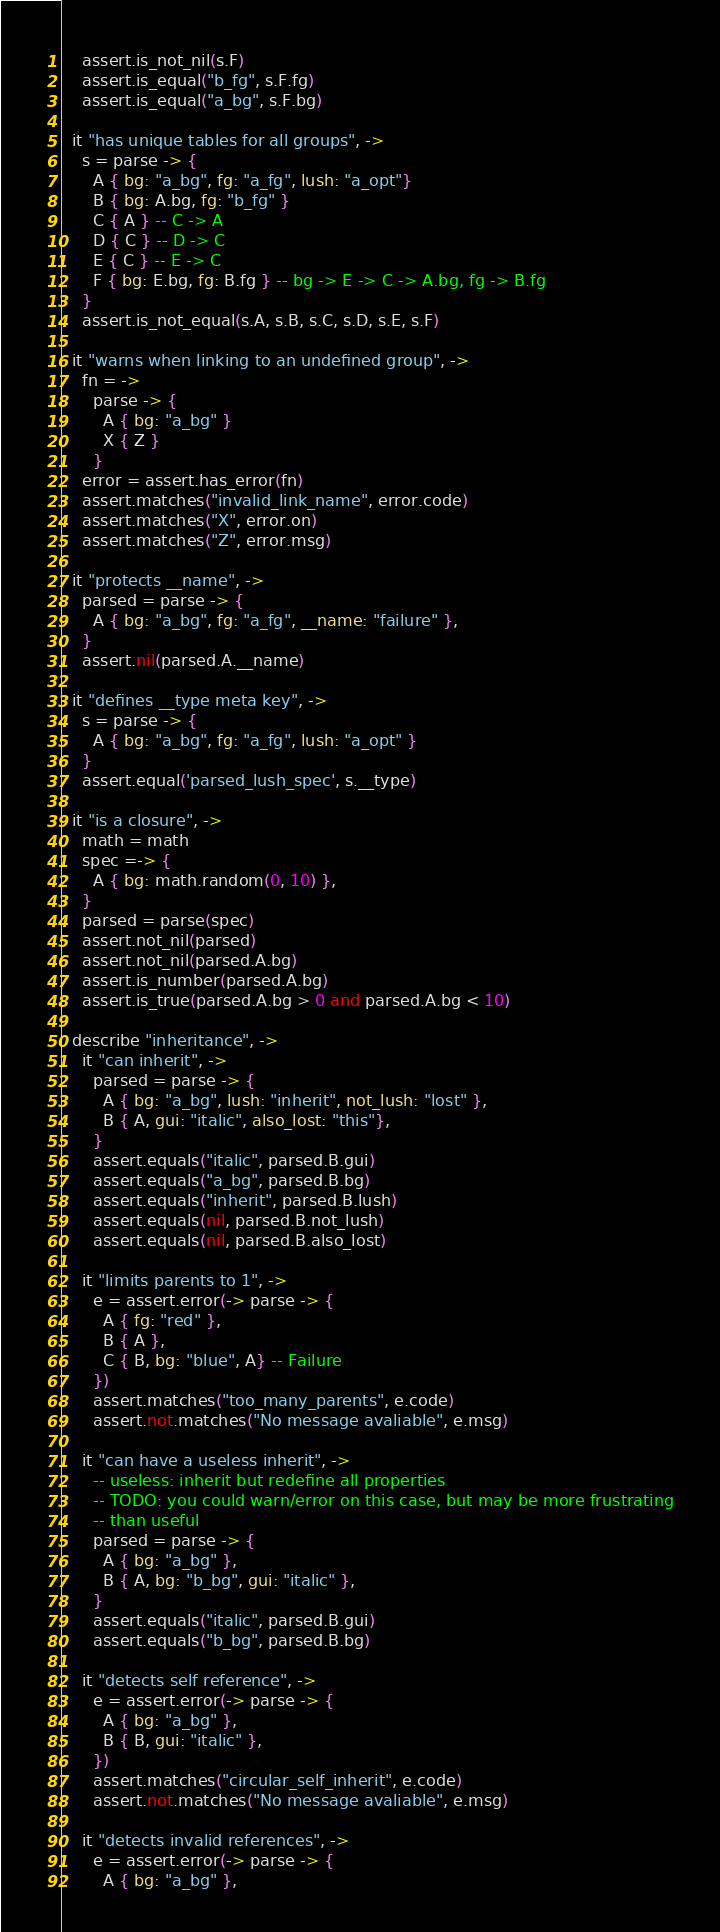Convert code to text. <code><loc_0><loc_0><loc_500><loc_500><_MoonScript_>    assert.is_not_nil(s.F)
    assert.is_equal("b_fg", s.F.fg)
    assert.is_equal("a_bg", s.F.bg)

  it "has unique tables for all groups", ->
    s = parse -> {
      A { bg: "a_bg", fg: "a_fg", lush: "a_opt"}
      B { bg: A.bg, fg: "b_fg" }
      C { A } -- C -> A
      D { C } -- D -> C
      E { C } -- E -> C
      F { bg: E.bg, fg: B.fg } -- bg -> E -> C -> A.bg, fg -> B.fg
    }
    assert.is_not_equal(s.A, s.B, s.C, s.D, s.E, s.F)

  it "warns when linking to an undefined group", ->
    fn = ->
      parse -> {
        A { bg: "a_bg" }
        X { Z }
      }
    error = assert.has_error(fn)
    assert.matches("invalid_link_name", error.code)
    assert.matches("X", error.on)
    assert.matches("Z", error.msg)

  it "protects __name", ->
    parsed = parse -> {
      A { bg: "a_bg", fg: "a_fg", __name: "failure" },
    }
    assert.nil(parsed.A.__name)

  it "defines __type meta key", ->
    s = parse -> {
      A { bg: "a_bg", fg: "a_fg", lush: "a_opt" }
    }
    assert.equal('parsed_lush_spec', s.__type)

  it "is a closure", ->
    math = math
    spec =-> {
      A { bg: math.random(0, 10) },
    }
    parsed = parse(spec)
    assert.not_nil(parsed)
    assert.not_nil(parsed.A.bg)
    assert.is_number(parsed.A.bg)
    assert.is_true(parsed.A.bg > 0 and parsed.A.bg < 10)

  describe "inheritance", ->
    it "can inherit", ->
      parsed = parse -> {
        A { bg: "a_bg", lush: "inherit", not_lush: "lost" },
        B { A, gui: "italic", also_lost: "this"},
      }
      assert.equals("italic", parsed.B.gui)
      assert.equals("a_bg", parsed.B.bg)
      assert.equals("inherit", parsed.B.lush)
      assert.equals(nil, parsed.B.not_lush)
      assert.equals(nil, parsed.B.also_lost)

    it "limits parents to 1", ->
      e = assert.error(-> parse -> {
        A { fg: "red" },
        B { A },
        C { B, bg: "blue", A} -- Failure
      })
      assert.matches("too_many_parents", e.code)
      assert.not.matches("No message avaliable", e.msg)

    it "can have a useless inherit", ->
      -- useless: inherit but redefine all properties
      -- TODO: you could warn/error on this case, but may be more frustrating
      -- than useful
      parsed = parse -> {
        A { bg: "a_bg" },
        B { A, bg: "b_bg", gui: "italic" },
      }
      assert.equals("italic", parsed.B.gui)
      assert.equals("b_bg", parsed.B.bg)

    it "detects self reference", ->
      e = assert.error(-> parse -> {
        A { bg: "a_bg" },
        B { B, gui: "italic" },
      })
      assert.matches("circular_self_inherit", e.code)
      assert.not.matches("No message avaliable", e.msg)

    it "detects invalid references", ->
      e = assert.error(-> parse -> {
        A { bg: "a_bg" },</code> 